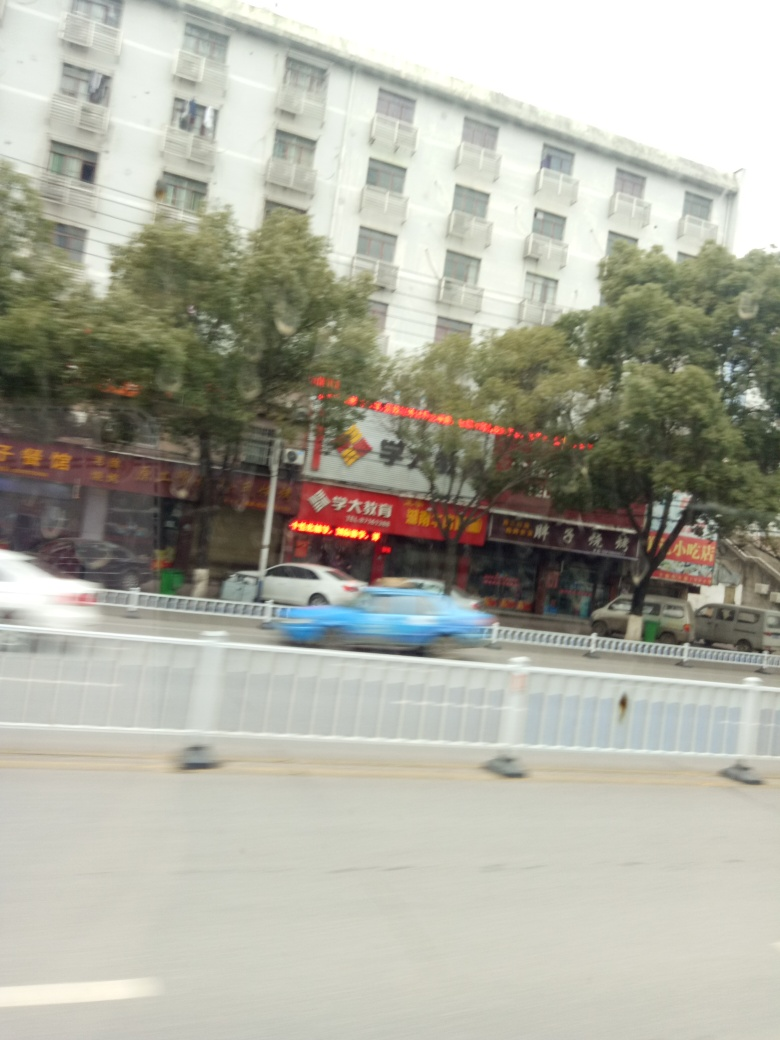Can you comment on the motion in the picture? Certainly, the image captures the dynamic nature of urban life. There's motion blur evident, particularly with the moving vehicles, suggesting that the photo was taken at a slower shutter speed, thus capturing the bustle of traffic passing by. 